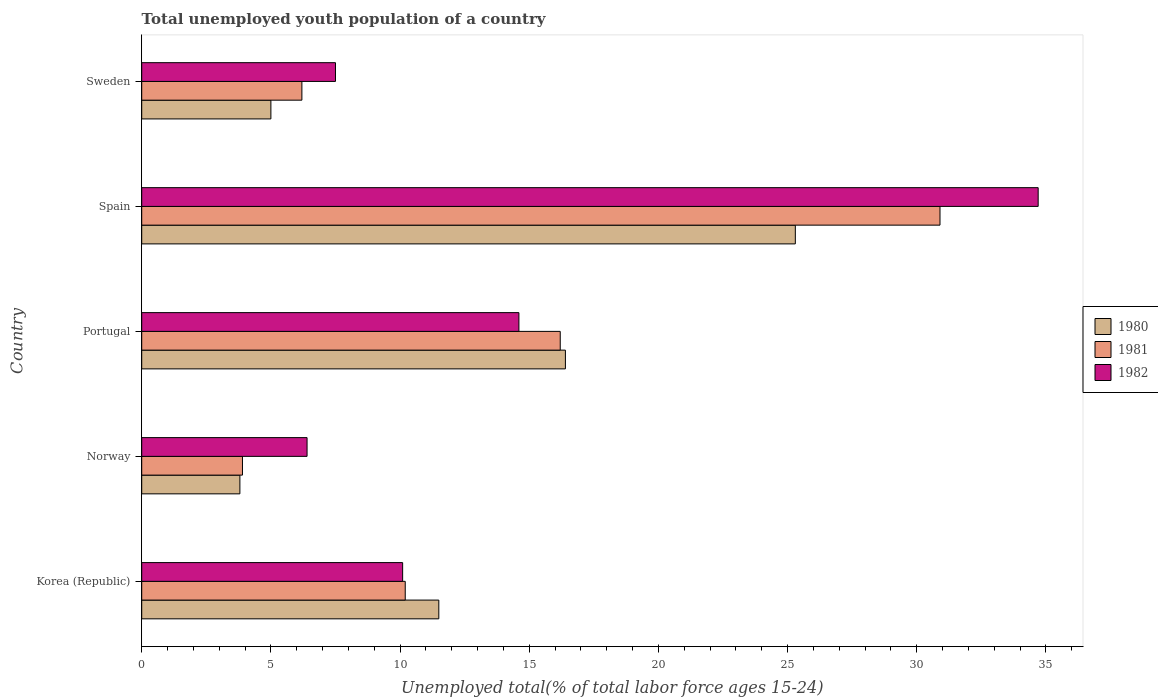How many groups of bars are there?
Provide a short and direct response. 5. Are the number of bars per tick equal to the number of legend labels?
Give a very brief answer. Yes. Are the number of bars on each tick of the Y-axis equal?
Ensure brevity in your answer.  Yes. How many bars are there on the 4th tick from the bottom?
Provide a succinct answer. 3. In how many cases, is the number of bars for a given country not equal to the number of legend labels?
Provide a succinct answer. 0. What is the percentage of total unemployed youth population of a country in 1980 in Spain?
Your response must be concise. 25.3. Across all countries, what is the maximum percentage of total unemployed youth population of a country in 1981?
Provide a succinct answer. 30.9. Across all countries, what is the minimum percentage of total unemployed youth population of a country in 1982?
Your answer should be very brief. 6.4. In which country was the percentage of total unemployed youth population of a country in 1981 minimum?
Ensure brevity in your answer.  Norway. What is the total percentage of total unemployed youth population of a country in 1981 in the graph?
Your answer should be very brief. 67.4. What is the difference between the percentage of total unemployed youth population of a country in 1980 in Norway and that in Portugal?
Ensure brevity in your answer.  -12.6. What is the difference between the percentage of total unemployed youth population of a country in 1980 in Spain and the percentage of total unemployed youth population of a country in 1981 in Portugal?
Make the answer very short. 9.1. What is the average percentage of total unemployed youth population of a country in 1982 per country?
Your answer should be compact. 14.66. What is the difference between the percentage of total unemployed youth population of a country in 1980 and percentage of total unemployed youth population of a country in 1982 in Spain?
Offer a terse response. -9.4. What is the ratio of the percentage of total unemployed youth population of a country in 1980 in Norway to that in Spain?
Provide a succinct answer. 0.15. Is the difference between the percentage of total unemployed youth population of a country in 1980 in Portugal and Spain greater than the difference between the percentage of total unemployed youth population of a country in 1982 in Portugal and Spain?
Ensure brevity in your answer.  Yes. What is the difference between the highest and the second highest percentage of total unemployed youth population of a country in 1982?
Make the answer very short. 20.1. What is the difference between the highest and the lowest percentage of total unemployed youth population of a country in 1982?
Provide a short and direct response. 28.3. What does the 2nd bar from the top in Portugal represents?
Your response must be concise. 1981. Does the graph contain grids?
Keep it short and to the point. No. Where does the legend appear in the graph?
Provide a short and direct response. Center right. How many legend labels are there?
Your answer should be compact. 3. How are the legend labels stacked?
Make the answer very short. Vertical. What is the title of the graph?
Your answer should be compact. Total unemployed youth population of a country. Does "2006" appear as one of the legend labels in the graph?
Keep it short and to the point. No. What is the label or title of the X-axis?
Provide a short and direct response. Unemployed total(% of total labor force ages 15-24). What is the Unemployed total(% of total labor force ages 15-24) of 1980 in Korea (Republic)?
Ensure brevity in your answer.  11.5. What is the Unemployed total(% of total labor force ages 15-24) of 1981 in Korea (Republic)?
Your response must be concise. 10.2. What is the Unemployed total(% of total labor force ages 15-24) in 1982 in Korea (Republic)?
Your answer should be compact. 10.1. What is the Unemployed total(% of total labor force ages 15-24) in 1980 in Norway?
Offer a terse response. 3.8. What is the Unemployed total(% of total labor force ages 15-24) in 1981 in Norway?
Offer a terse response. 3.9. What is the Unemployed total(% of total labor force ages 15-24) of 1982 in Norway?
Offer a very short reply. 6.4. What is the Unemployed total(% of total labor force ages 15-24) of 1980 in Portugal?
Your answer should be compact. 16.4. What is the Unemployed total(% of total labor force ages 15-24) in 1981 in Portugal?
Provide a succinct answer. 16.2. What is the Unemployed total(% of total labor force ages 15-24) in 1982 in Portugal?
Your answer should be compact. 14.6. What is the Unemployed total(% of total labor force ages 15-24) of 1980 in Spain?
Offer a terse response. 25.3. What is the Unemployed total(% of total labor force ages 15-24) of 1981 in Spain?
Your answer should be very brief. 30.9. What is the Unemployed total(% of total labor force ages 15-24) in 1982 in Spain?
Keep it short and to the point. 34.7. What is the Unemployed total(% of total labor force ages 15-24) in 1981 in Sweden?
Your answer should be compact. 6.2. Across all countries, what is the maximum Unemployed total(% of total labor force ages 15-24) in 1980?
Ensure brevity in your answer.  25.3. Across all countries, what is the maximum Unemployed total(% of total labor force ages 15-24) in 1981?
Give a very brief answer. 30.9. Across all countries, what is the maximum Unemployed total(% of total labor force ages 15-24) in 1982?
Ensure brevity in your answer.  34.7. Across all countries, what is the minimum Unemployed total(% of total labor force ages 15-24) of 1980?
Your answer should be compact. 3.8. Across all countries, what is the minimum Unemployed total(% of total labor force ages 15-24) in 1981?
Provide a short and direct response. 3.9. Across all countries, what is the minimum Unemployed total(% of total labor force ages 15-24) in 1982?
Provide a succinct answer. 6.4. What is the total Unemployed total(% of total labor force ages 15-24) of 1981 in the graph?
Offer a very short reply. 67.4. What is the total Unemployed total(% of total labor force ages 15-24) of 1982 in the graph?
Your answer should be very brief. 73.3. What is the difference between the Unemployed total(% of total labor force ages 15-24) in 1981 in Korea (Republic) and that in Norway?
Your answer should be very brief. 6.3. What is the difference between the Unemployed total(% of total labor force ages 15-24) of 1981 in Korea (Republic) and that in Spain?
Your answer should be very brief. -20.7. What is the difference between the Unemployed total(% of total labor force ages 15-24) of 1982 in Korea (Republic) and that in Spain?
Your answer should be compact. -24.6. What is the difference between the Unemployed total(% of total labor force ages 15-24) in 1980 in Korea (Republic) and that in Sweden?
Ensure brevity in your answer.  6.5. What is the difference between the Unemployed total(% of total labor force ages 15-24) in 1981 in Korea (Republic) and that in Sweden?
Give a very brief answer. 4. What is the difference between the Unemployed total(% of total labor force ages 15-24) in 1982 in Korea (Republic) and that in Sweden?
Ensure brevity in your answer.  2.6. What is the difference between the Unemployed total(% of total labor force ages 15-24) of 1981 in Norway and that in Portugal?
Your answer should be very brief. -12.3. What is the difference between the Unemployed total(% of total labor force ages 15-24) of 1980 in Norway and that in Spain?
Offer a terse response. -21.5. What is the difference between the Unemployed total(% of total labor force ages 15-24) in 1981 in Norway and that in Spain?
Give a very brief answer. -27. What is the difference between the Unemployed total(% of total labor force ages 15-24) of 1982 in Norway and that in Spain?
Keep it short and to the point. -28.3. What is the difference between the Unemployed total(% of total labor force ages 15-24) in 1981 in Norway and that in Sweden?
Offer a very short reply. -2.3. What is the difference between the Unemployed total(% of total labor force ages 15-24) of 1981 in Portugal and that in Spain?
Offer a very short reply. -14.7. What is the difference between the Unemployed total(% of total labor force ages 15-24) of 1982 in Portugal and that in Spain?
Provide a short and direct response. -20.1. What is the difference between the Unemployed total(% of total labor force ages 15-24) of 1980 in Portugal and that in Sweden?
Keep it short and to the point. 11.4. What is the difference between the Unemployed total(% of total labor force ages 15-24) in 1981 in Portugal and that in Sweden?
Provide a succinct answer. 10. What is the difference between the Unemployed total(% of total labor force ages 15-24) of 1982 in Portugal and that in Sweden?
Provide a succinct answer. 7.1. What is the difference between the Unemployed total(% of total labor force ages 15-24) of 1980 in Spain and that in Sweden?
Your answer should be very brief. 20.3. What is the difference between the Unemployed total(% of total labor force ages 15-24) of 1981 in Spain and that in Sweden?
Your answer should be very brief. 24.7. What is the difference between the Unemployed total(% of total labor force ages 15-24) in 1982 in Spain and that in Sweden?
Keep it short and to the point. 27.2. What is the difference between the Unemployed total(% of total labor force ages 15-24) in 1980 in Korea (Republic) and the Unemployed total(% of total labor force ages 15-24) in 1981 in Norway?
Keep it short and to the point. 7.6. What is the difference between the Unemployed total(% of total labor force ages 15-24) in 1981 in Korea (Republic) and the Unemployed total(% of total labor force ages 15-24) in 1982 in Norway?
Give a very brief answer. 3.8. What is the difference between the Unemployed total(% of total labor force ages 15-24) of 1980 in Korea (Republic) and the Unemployed total(% of total labor force ages 15-24) of 1982 in Portugal?
Give a very brief answer. -3.1. What is the difference between the Unemployed total(% of total labor force ages 15-24) in 1981 in Korea (Republic) and the Unemployed total(% of total labor force ages 15-24) in 1982 in Portugal?
Provide a short and direct response. -4.4. What is the difference between the Unemployed total(% of total labor force ages 15-24) of 1980 in Korea (Republic) and the Unemployed total(% of total labor force ages 15-24) of 1981 in Spain?
Provide a short and direct response. -19.4. What is the difference between the Unemployed total(% of total labor force ages 15-24) of 1980 in Korea (Republic) and the Unemployed total(% of total labor force ages 15-24) of 1982 in Spain?
Make the answer very short. -23.2. What is the difference between the Unemployed total(% of total labor force ages 15-24) in 1981 in Korea (Republic) and the Unemployed total(% of total labor force ages 15-24) in 1982 in Spain?
Ensure brevity in your answer.  -24.5. What is the difference between the Unemployed total(% of total labor force ages 15-24) in 1980 in Korea (Republic) and the Unemployed total(% of total labor force ages 15-24) in 1981 in Sweden?
Offer a terse response. 5.3. What is the difference between the Unemployed total(% of total labor force ages 15-24) in 1981 in Korea (Republic) and the Unemployed total(% of total labor force ages 15-24) in 1982 in Sweden?
Make the answer very short. 2.7. What is the difference between the Unemployed total(% of total labor force ages 15-24) of 1980 in Norway and the Unemployed total(% of total labor force ages 15-24) of 1981 in Spain?
Your answer should be compact. -27.1. What is the difference between the Unemployed total(% of total labor force ages 15-24) of 1980 in Norway and the Unemployed total(% of total labor force ages 15-24) of 1982 in Spain?
Offer a very short reply. -30.9. What is the difference between the Unemployed total(% of total labor force ages 15-24) in 1981 in Norway and the Unemployed total(% of total labor force ages 15-24) in 1982 in Spain?
Offer a very short reply. -30.8. What is the difference between the Unemployed total(% of total labor force ages 15-24) in 1980 in Portugal and the Unemployed total(% of total labor force ages 15-24) in 1982 in Spain?
Ensure brevity in your answer.  -18.3. What is the difference between the Unemployed total(% of total labor force ages 15-24) of 1981 in Portugal and the Unemployed total(% of total labor force ages 15-24) of 1982 in Spain?
Ensure brevity in your answer.  -18.5. What is the difference between the Unemployed total(% of total labor force ages 15-24) of 1980 in Spain and the Unemployed total(% of total labor force ages 15-24) of 1981 in Sweden?
Give a very brief answer. 19.1. What is the difference between the Unemployed total(% of total labor force ages 15-24) of 1980 in Spain and the Unemployed total(% of total labor force ages 15-24) of 1982 in Sweden?
Your response must be concise. 17.8. What is the difference between the Unemployed total(% of total labor force ages 15-24) of 1981 in Spain and the Unemployed total(% of total labor force ages 15-24) of 1982 in Sweden?
Offer a terse response. 23.4. What is the average Unemployed total(% of total labor force ages 15-24) in 1981 per country?
Provide a succinct answer. 13.48. What is the average Unemployed total(% of total labor force ages 15-24) of 1982 per country?
Your answer should be very brief. 14.66. What is the difference between the Unemployed total(% of total labor force ages 15-24) of 1980 and Unemployed total(% of total labor force ages 15-24) of 1981 in Korea (Republic)?
Provide a succinct answer. 1.3. What is the difference between the Unemployed total(% of total labor force ages 15-24) in 1980 and Unemployed total(% of total labor force ages 15-24) in 1982 in Korea (Republic)?
Ensure brevity in your answer.  1.4. What is the difference between the Unemployed total(% of total labor force ages 15-24) of 1981 and Unemployed total(% of total labor force ages 15-24) of 1982 in Korea (Republic)?
Your answer should be very brief. 0.1. What is the difference between the Unemployed total(% of total labor force ages 15-24) in 1980 and Unemployed total(% of total labor force ages 15-24) in 1981 in Norway?
Offer a very short reply. -0.1. What is the difference between the Unemployed total(% of total labor force ages 15-24) in 1980 and Unemployed total(% of total labor force ages 15-24) in 1982 in Norway?
Keep it short and to the point. -2.6. What is the difference between the Unemployed total(% of total labor force ages 15-24) in 1981 and Unemployed total(% of total labor force ages 15-24) in 1982 in Norway?
Keep it short and to the point. -2.5. What is the difference between the Unemployed total(% of total labor force ages 15-24) of 1980 and Unemployed total(% of total labor force ages 15-24) of 1981 in Portugal?
Provide a short and direct response. 0.2. What is the difference between the Unemployed total(% of total labor force ages 15-24) of 1980 and Unemployed total(% of total labor force ages 15-24) of 1981 in Sweden?
Provide a succinct answer. -1.2. What is the ratio of the Unemployed total(% of total labor force ages 15-24) of 1980 in Korea (Republic) to that in Norway?
Provide a succinct answer. 3.03. What is the ratio of the Unemployed total(% of total labor force ages 15-24) of 1981 in Korea (Republic) to that in Norway?
Provide a succinct answer. 2.62. What is the ratio of the Unemployed total(% of total labor force ages 15-24) of 1982 in Korea (Republic) to that in Norway?
Keep it short and to the point. 1.58. What is the ratio of the Unemployed total(% of total labor force ages 15-24) of 1980 in Korea (Republic) to that in Portugal?
Your answer should be compact. 0.7. What is the ratio of the Unemployed total(% of total labor force ages 15-24) of 1981 in Korea (Republic) to that in Portugal?
Ensure brevity in your answer.  0.63. What is the ratio of the Unemployed total(% of total labor force ages 15-24) of 1982 in Korea (Republic) to that in Portugal?
Your response must be concise. 0.69. What is the ratio of the Unemployed total(% of total labor force ages 15-24) of 1980 in Korea (Republic) to that in Spain?
Keep it short and to the point. 0.45. What is the ratio of the Unemployed total(% of total labor force ages 15-24) of 1981 in Korea (Republic) to that in Spain?
Offer a very short reply. 0.33. What is the ratio of the Unemployed total(% of total labor force ages 15-24) of 1982 in Korea (Republic) to that in Spain?
Give a very brief answer. 0.29. What is the ratio of the Unemployed total(% of total labor force ages 15-24) of 1981 in Korea (Republic) to that in Sweden?
Offer a terse response. 1.65. What is the ratio of the Unemployed total(% of total labor force ages 15-24) of 1982 in Korea (Republic) to that in Sweden?
Offer a terse response. 1.35. What is the ratio of the Unemployed total(% of total labor force ages 15-24) of 1980 in Norway to that in Portugal?
Your answer should be compact. 0.23. What is the ratio of the Unemployed total(% of total labor force ages 15-24) in 1981 in Norway to that in Portugal?
Make the answer very short. 0.24. What is the ratio of the Unemployed total(% of total labor force ages 15-24) of 1982 in Norway to that in Portugal?
Keep it short and to the point. 0.44. What is the ratio of the Unemployed total(% of total labor force ages 15-24) of 1980 in Norway to that in Spain?
Give a very brief answer. 0.15. What is the ratio of the Unemployed total(% of total labor force ages 15-24) of 1981 in Norway to that in Spain?
Offer a terse response. 0.13. What is the ratio of the Unemployed total(% of total labor force ages 15-24) of 1982 in Norway to that in Spain?
Offer a very short reply. 0.18. What is the ratio of the Unemployed total(% of total labor force ages 15-24) of 1980 in Norway to that in Sweden?
Give a very brief answer. 0.76. What is the ratio of the Unemployed total(% of total labor force ages 15-24) in 1981 in Norway to that in Sweden?
Offer a very short reply. 0.63. What is the ratio of the Unemployed total(% of total labor force ages 15-24) in 1982 in Norway to that in Sweden?
Your answer should be compact. 0.85. What is the ratio of the Unemployed total(% of total labor force ages 15-24) in 1980 in Portugal to that in Spain?
Offer a terse response. 0.65. What is the ratio of the Unemployed total(% of total labor force ages 15-24) in 1981 in Portugal to that in Spain?
Keep it short and to the point. 0.52. What is the ratio of the Unemployed total(% of total labor force ages 15-24) of 1982 in Portugal to that in Spain?
Your answer should be compact. 0.42. What is the ratio of the Unemployed total(% of total labor force ages 15-24) in 1980 in Portugal to that in Sweden?
Offer a terse response. 3.28. What is the ratio of the Unemployed total(% of total labor force ages 15-24) in 1981 in Portugal to that in Sweden?
Give a very brief answer. 2.61. What is the ratio of the Unemployed total(% of total labor force ages 15-24) of 1982 in Portugal to that in Sweden?
Your answer should be very brief. 1.95. What is the ratio of the Unemployed total(% of total labor force ages 15-24) of 1980 in Spain to that in Sweden?
Provide a succinct answer. 5.06. What is the ratio of the Unemployed total(% of total labor force ages 15-24) in 1981 in Spain to that in Sweden?
Offer a terse response. 4.98. What is the ratio of the Unemployed total(% of total labor force ages 15-24) of 1982 in Spain to that in Sweden?
Offer a very short reply. 4.63. What is the difference between the highest and the second highest Unemployed total(% of total labor force ages 15-24) of 1982?
Give a very brief answer. 20.1. What is the difference between the highest and the lowest Unemployed total(% of total labor force ages 15-24) in 1980?
Offer a terse response. 21.5. What is the difference between the highest and the lowest Unemployed total(% of total labor force ages 15-24) of 1982?
Make the answer very short. 28.3. 